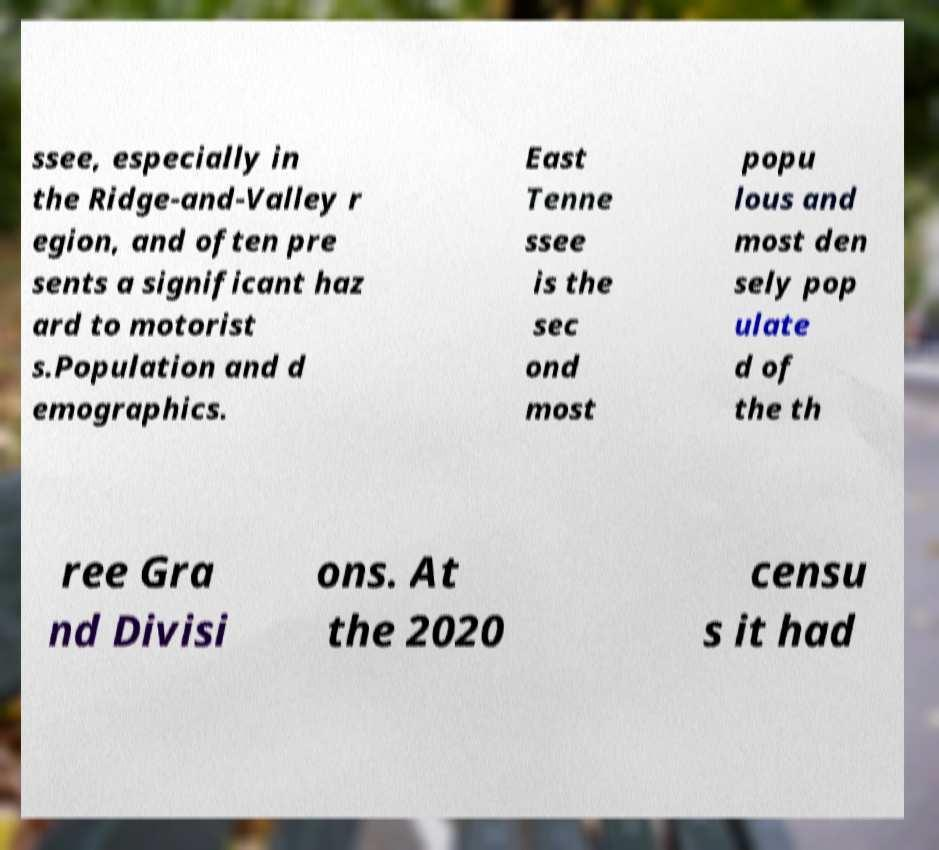What messages or text are displayed in this image? I need them in a readable, typed format. ssee, especially in the Ridge-and-Valley r egion, and often pre sents a significant haz ard to motorist s.Population and d emographics. East Tenne ssee is the sec ond most popu lous and most den sely pop ulate d of the th ree Gra nd Divisi ons. At the 2020 censu s it had 